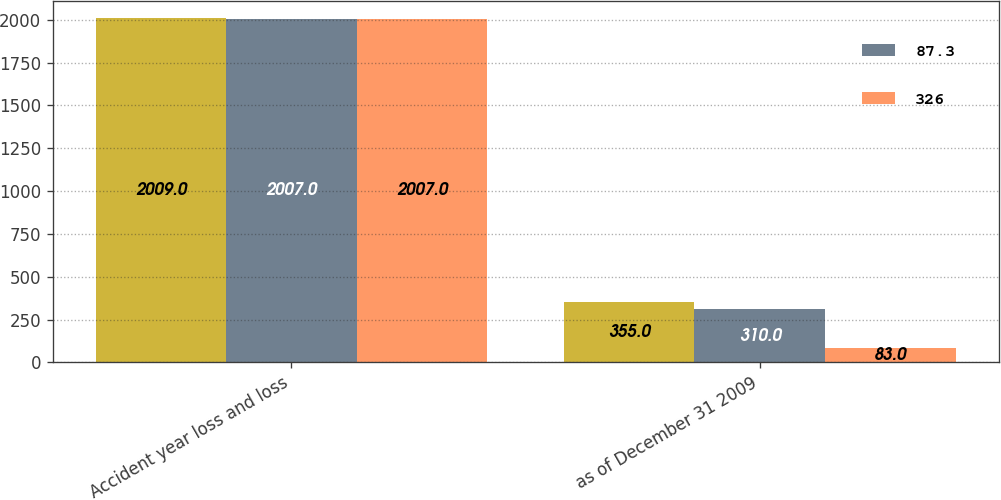Convert chart. <chart><loc_0><loc_0><loc_500><loc_500><stacked_bar_chart><ecel><fcel>Accident year loss and loss<fcel>as of December 31 2009<nl><fcel>nan<fcel>2009<fcel>355<nl><fcel>87.3<fcel>2007<fcel>310<nl><fcel>326<fcel>2007<fcel>83<nl></chart> 